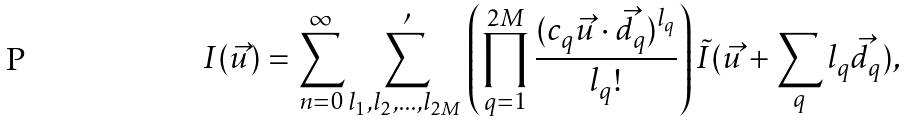<formula> <loc_0><loc_0><loc_500><loc_500>I ( \vec { u } ) = \sum _ { n = 0 } ^ { \infty } \sum _ { l _ { 1 } , l _ { 2 } , \dots , l _ { 2 M } } ^ { \prime } \left ( \prod _ { q = 1 } ^ { 2 M } \frac { ( c _ { q } \vec { u } \cdot \vec { d } _ { q } ) ^ { l _ { q } } } { l _ { q } ! } \right ) \tilde { I } ( \vec { u } + \sum _ { q } l _ { q } \vec { d } _ { q } ) ,</formula> 